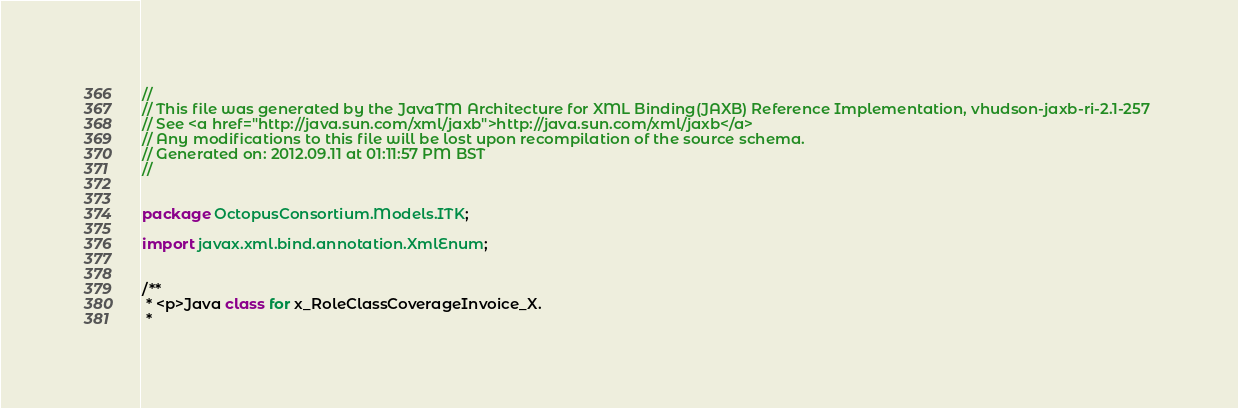Convert code to text. <code><loc_0><loc_0><loc_500><loc_500><_Java_>//
// This file was generated by the JavaTM Architecture for XML Binding(JAXB) Reference Implementation, vhudson-jaxb-ri-2.1-257 
// See <a href="http://java.sun.com/xml/jaxb">http://java.sun.com/xml/jaxb</a> 
// Any modifications to this file will be lost upon recompilation of the source schema. 
// Generated on: 2012.09.11 at 01:11:57 PM BST 
//


package OctopusConsortium.Models.ITK;

import javax.xml.bind.annotation.XmlEnum;


/**
 * <p>Java class for x_RoleClassCoverageInvoice_X.
 * </code> 